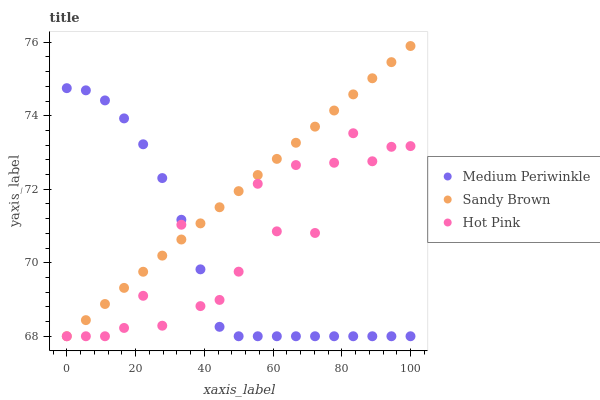Does Medium Periwinkle have the minimum area under the curve?
Answer yes or no. Yes. Does Sandy Brown have the maximum area under the curve?
Answer yes or no. Yes. Does Hot Pink have the minimum area under the curve?
Answer yes or no. No. Does Hot Pink have the maximum area under the curve?
Answer yes or no. No. Is Sandy Brown the smoothest?
Answer yes or no. Yes. Is Hot Pink the roughest?
Answer yes or no. Yes. Is Medium Periwinkle the smoothest?
Answer yes or no. No. Is Medium Periwinkle the roughest?
Answer yes or no. No. Does Sandy Brown have the lowest value?
Answer yes or no. Yes. Does Sandy Brown have the highest value?
Answer yes or no. Yes. Does Medium Periwinkle have the highest value?
Answer yes or no. No. Does Hot Pink intersect Medium Periwinkle?
Answer yes or no. Yes. Is Hot Pink less than Medium Periwinkle?
Answer yes or no. No. Is Hot Pink greater than Medium Periwinkle?
Answer yes or no. No. 